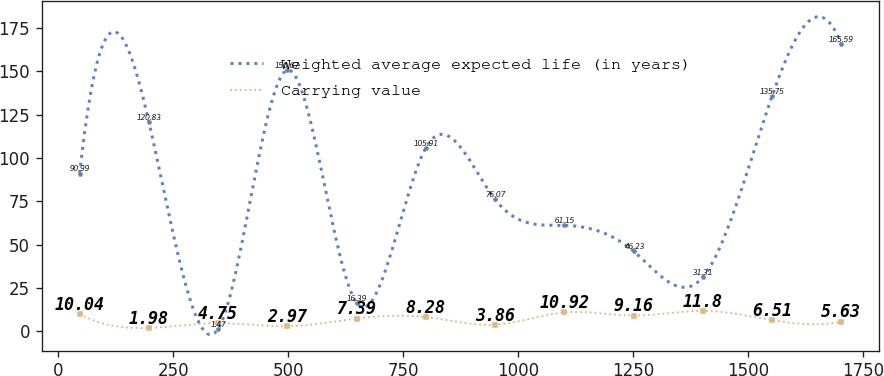Convert chart to OTSL. <chart><loc_0><loc_0><loc_500><loc_500><line_chart><ecel><fcel>Weighted average expected life (in years)<fcel>Carrying value<nl><fcel>46.77<fcel>90.99<fcel>10.04<nl><fcel>197.3<fcel>120.83<fcel>1.98<nl><fcel>347.83<fcel>1.47<fcel>4.75<nl><fcel>498.36<fcel>150.67<fcel>2.97<nl><fcel>648.89<fcel>16.39<fcel>7.39<nl><fcel>799.42<fcel>105.91<fcel>8.28<nl><fcel>949.95<fcel>76.07<fcel>3.86<nl><fcel>1100.48<fcel>61.15<fcel>10.92<nl><fcel>1251.01<fcel>46.23<fcel>9.16<nl><fcel>1401.54<fcel>31.31<fcel>11.8<nl><fcel>1552.07<fcel>135.75<fcel>6.51<nl><fcel>1702.6<fcel>165.59<fcel>5.63<nl></chart> 